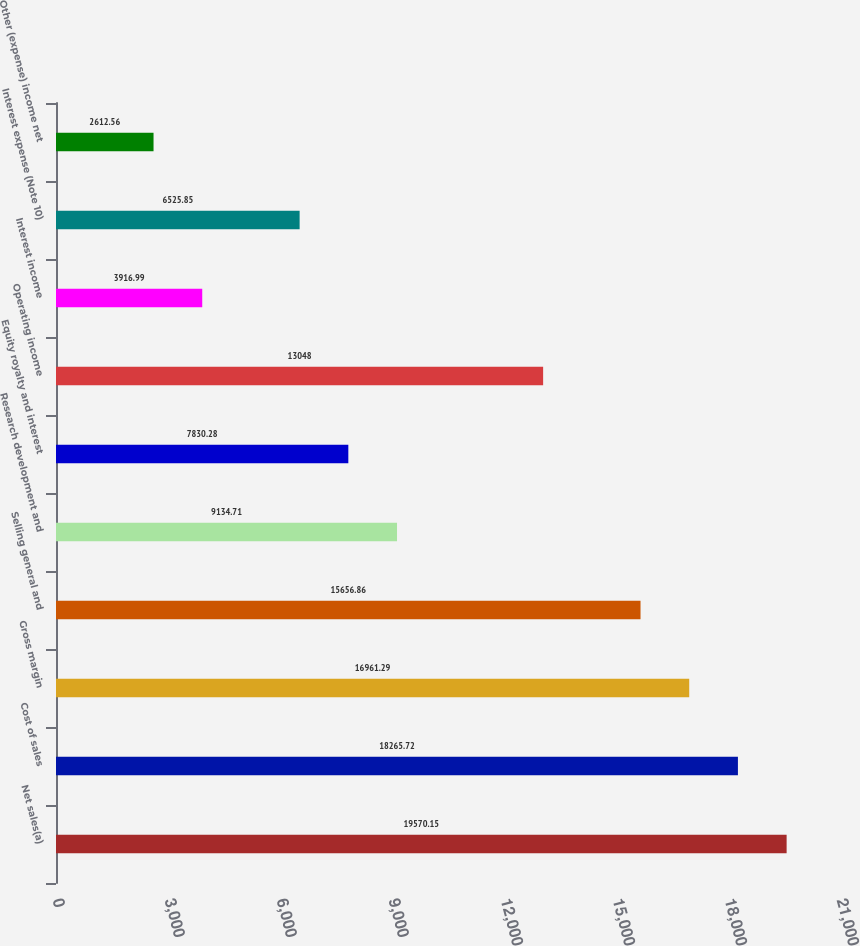<chart> <loc_0><loc_0><loc_500><loc_500><bar_chart><fcel>Net sales(a)<fcel>Cost of sales<fcel>Gross margin<fcel>Selling general and<fcel>Research development and<fcel>Equity royalty and interest<fcel>Operating income<fcel>Interest income<fcel>Interest expense (Note 10)<fcel>Other (expense) income net<nl><fcel>19570.2<fcel>18265.7<fcel>16961.3<fcel>15656.9<fcel>9134.71<fcel>7830.28<fcel>13048<fcel>3916.99<fcel>6525.85<fcel>2612.56<nl></chart> 